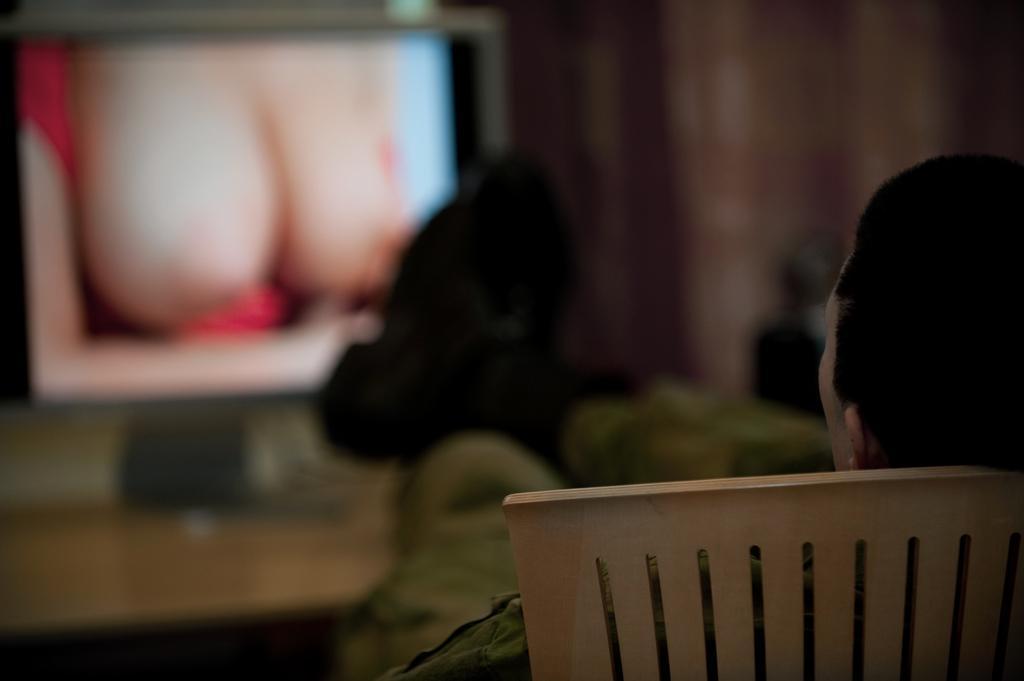In one or two sentences, can you explain what this image depicts? On the right side of the image we can see a person is seated on the chair and we can see blurry background. 